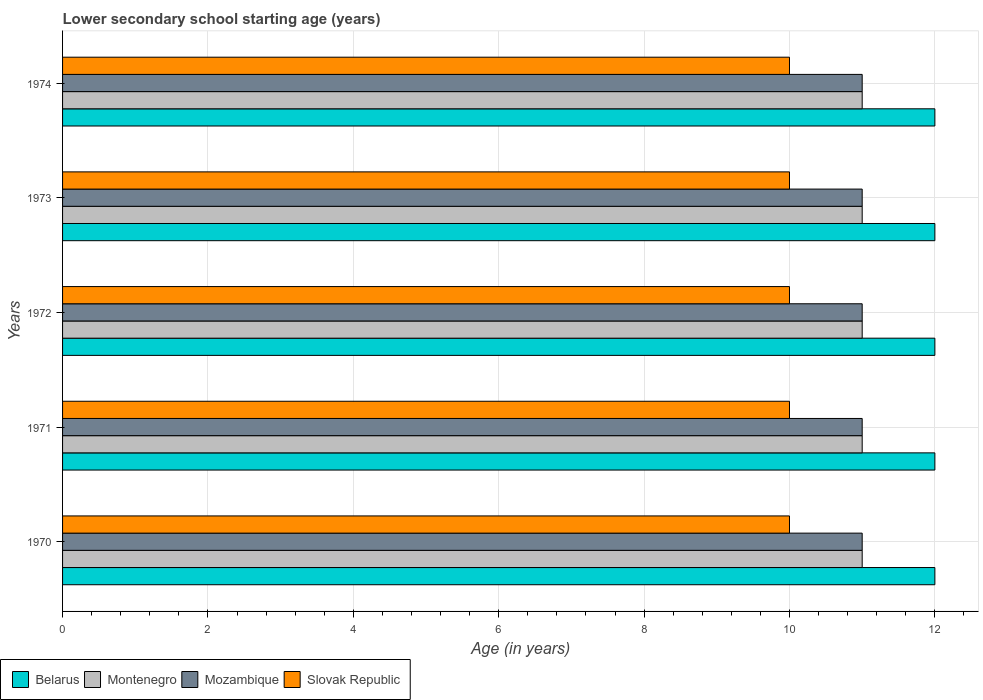How many different coloured bars are there?
Your answer should be compact. 4. Are the number of bars per tick equal to the number of legend labels?
Provide a short and direct response. Yes. Are the number of bars on each tick of the Y-axis equal?
Your answer should be very brief. Yes. How many bars are there on the 4th tick from the bottom?
Give a very brief answer. 4. In how many cases, is the number of bars for a given year not equal to the number of legend labels?
Provide a succinct answer. 0. What is the lower secondary school starting age of children in Montenegro in 1972?
Provide a succinct answer. 11. Across all years, what is the maximum lower secondary school starting age of children in Montenegro?
Your response must be concise. 11. Across all years, what is the minimum lower secondary school starting age of children in Mozambique?
Make the answer very short. 11. In which year was the lower secondary school starting age of children in Slovak Republic maximum?
Your answer should be compact. 1970. In which year was the lower secondary school starting age of children in Montenegro minimum?
Provide a short and direct response. 1970. What is the total lower secondary school starting age of children in Belarus in the graph?
Your response must be concise. 60. What is the difference between the lower secondary school starting age of children in Montenegro in 1972 and that in 1974?
Your response must be concise. 0. What is the difference between the lower secondary school starting age of children in Slovak Republic in 1971 and the lower secondary school starting age of children in Montenegro in 1974?
Provide a short and direct response. -1. What is the average lower secondary school starting age of children in Belarus per year?
Your response must be concise. 12. In the year 1970, what is the difference between the lower secondary school starting age of children in Montenegro and lower secondary school starting age of children in Mozambique?
Offer a terse response. 0. What is the ratio of the lower secondary school starting age of children in Belarus in 1972 to that in 1973?
Your answer should be compact. 1. Is the lower secondary school starting age of children in Mozambique in 1971 less than that in 1972?
Offer a very short reply. No. Is the difference between the lower secondary school starting age of children in Montenegro in 1972 and 1973 greater than the difference between the lower secondary school starting age of children in Mozambique in 1972 and 1973?
Ensure brevity in your answer.  No. What is the difference between the highest and the second highest lower secondary school starting age of children in Slovak Republic?
Your response must be concise. 0. What is the difference between the highest and the lowest lower secondary school starting age of children in Montenegro?
Offer a terse response. 0. Is the sum of the lower secondary school starting age of children in Slovak Republic in 1971 and 1974 greater than the maximum lower secondary school starting age of children in Mozambique across all years?
Ensure brevity in your answer.  Yes. Is it the case that in every year, the sum of the lower secondary school starting age of children in Mozambique and lower secondary school starting age of children in Belarus is greater than the sum of lower secondary school starting age of children in Slovak Republic and lower secondary school starting age of children in Montenegro?
Your response must be concise. Yes. What does the 1st bar from the top in 1971 represents?
Provide a succinct answer. Slovak Republic. What does the 2nd bar from the bottom in 1974 represents?
Offer a very short reply. Montenegro. How many bars are there?
Provide a succinct answer. 20. Are all the bars in the graph horizontal?
Make the answer very short. Yes. Are the values on the major ticks of X-axis written in scientific E-notation?
Give a very brief answer. No. Where does the legend appear in the graph?
Your response must be concise. Bottom left. How many legend labels are there?
Your answer should be compact. 4. How are the legend labels stacked?
Offer a very short reply. Horizontal. What is the title of the graph?
Offer a terse response. Lower secondary school starting age (years). What is the label or title of the X-axis?
Keep it short and to the point. Age (in years). What is the Age (in years) of Belarus in 1970?
Your answer should be compact. 12. What is the Age (in years) of Montenegro in 1970?
Your answer should be compact. 11. What is the Age (in years) in Mozambique in 1970?
Offer a terse response. 11. What is the Age (in years) of Montenegro in 1971?
Provide a short and direct response. 11. What is the Age (in years) in Belarus in 1973?
Ensure brevity in your answer.  12. What is the Age (in years) of Mozambique in 1973?
Your response must be concise. 11. What is the Age (in years) in Slovak Republic in 1973?
Make the answer very short. 10. What is the Age (in years) of Belarus in 1974?
Offer a terse response. 12. What is the Age (in years) in Slovak Republic in 1974?
Your answer should be compact. 10. Across all years, what is the maximum Age (in years) of Mozambique?
Your response must be concise. 11. Across all years, what is the maximum Age (in years) in Slovak Republic?
Your response must be concise. 10. Across all years, what is the minimum Age (in years) in Montenegro?
Your answer should be compact. 11. Across all years, what is the minimum Age (in years) in Mozambique?
Make the answer very short. 11. Across all years, what is the minimum Age (in years) in Slovak Republic?
Offer a terse response. 10. What is the total Age (in years) in Belarus in the graph?
Offer a terse response. 60. What is the total Age (in years) of Slovak Republic in the graph?
Keep it short and to the point. 50. What is the difference between the Age (in years) of Belarus in 1970 and that in 1971?
Offer a terse response. 0. What is the difference between the Age (in years) of Mozambique in 1970 and that in 1971?
Offer a terse response. 0. What is the difference between the Age (in years) in Slovak Republic in 1970 and that in 1971?
Give a very brief answer. 0. What is the difference between the Age (in years) in Belarus in 1970 and that in 1972?
Your answer should be very brief. 0. What is the difference between the Age (in years) in Montenegro in 1970 and that in 1972?
Ensure brevity in your answer.  0. What is the difference between the Age (in years) of Slovak Republic in 1970 and that in 1972?
Give a very brief answer. 0. What is the difference between the Age (in years) of Belarus in 1970 and that in 1973?
Keep it short and to the point. 0. What is the difference between the Age (in years) of Mozambique in 1970 and that in 1973?
Give a very brief answer. 0. What is the difference between the Age (in years) in Slovak Republic in 1970 and that in 1973?
Your answer should be very brief. 0. What is the difference between the Age (in years) in Belarus in 1970 and that in 1974?
Give a very brief answer. 0. What is the difference between the Age (in years) in Montenegro in 1970 and that in 1974?
Ensure brevity in your answer.  0. What is the difference between the Age (in years) of Mozambique in 1970 and that in 1974?
Make the answer very short. 0. What is the difference between the Age (in years) of Belarus in 1971 and that in 1972?
Provide a short and direct response. 0. What is the difference between the Age (in years) in Montenegro in 1971 and that in 1972?
Ensure brevity in your answer.  0. What is the difference between the Age (in years) of Mozambique in 1971 and that in 1972?
Make the answer very short. 0. What is the difference between the Age (in years) in Belarus in 1971 and that in 1973?
Offer a terse response. 0. What is the difference between the Age (in years) of Montenegro in 1971 and that in 1973?
Your answer should be very brief. 0. What is the difference between the Age (in years) of Mozambique in 1971 and that in 1973?
Give a very brief answer. 0. What is the difference between the Age (in years) of Mozambique in 1971 and that in 1974?
Offer a terse response. 0. What is the difference between the Age (in years) of Belarus in 1972 and that in 1973?
Your answer should be very brief. 0. What is the difference between the Age (in years) in Montenegro in 1972 and that in 1973?
Keep it short and to the point. 0. What is the difference between the Age (in years) in Slovak Republic in 1972 and that in 1973?
Your answer should be compact. 0. What is the difference between the Age (in years) of Belarus in 1972 and that in 1974?
Offer a terse response. 0. What is the difference between the Age (in years) in Mozambique in 1972 and that in 1974?
Your answer should be compact. 0. What is the difference between the Age (in years) of Slovak Republic in 1972 and that in 1974?
Ensure brevity in your answer.  0. What is the difference between the Age (in years) in Belarus in 1973 and that in 1974?
Provide a succinct answer. 0. What is the difference between the Age (in years) in Montenegro in 1973 and that in 1974?
Make the answer very short. 0. What is the difference between the Age (in years) in Belarus in 1970 and the Age (in years) in Montenegro in 1971?
Your answer should be very brief. 1. What is the difference between the Age (in years) of Belarus in 1970 and the Age (in years) of Slovak Republic in 1971?
Keep it short and to the point. 2. What is the difference between the Age (in years) of Montenegro in 1970 and the Age (in years) of Slovak Republic in 1971?
Offer a terse response. 1. What is the difference between the Age (in years) in Belarus in 1970 and the Age (in years) in Montenegro in 1972?
Make the answer very short. 1. What is the difference between the Age (in years) in Montenegro in 1970 and the Age (in years) in Mozambique in 1972?
Keep it short and to the point. 0. What is the difference between the Age (in years) in Montenegro in 1970 and the Age (in years) in Slovak Republic in 1972?
Offer a terse response. 1. What is the difference between the Age (in years) of Belarus in 1970 and the Age (in years) of Montenegro in 1973?
Provide a succinct answer. 1. What is the difference between the Age (in years) in Belarus in 1970 and the Age (in years) in Mozambique in 1973?
Offer a very short reply. 1. What is the difference between the Age (in years) of Belarus in 1970 and the Age (in years) of Slovak Republic in 1973?
Your answer should be compact. 2. What is the difference between the Age (in years) of Montenegro in 1970 and the Age (in years) of Mozambique in 1973?
Provide a succinct answer. 0. What is the difference between the Age (in years) of Montenegro in 1970 and the Age (in years) of Slovak Republic in 1973?
Make the answer very short. 1. What is the difference between the Age (in years) in Mozambique in 1970 and the Age (in years) in Slovak Republic in 1973?
Offer a terse response. 1. What is the difference between the Age (in years) of Belarus in 1970 and the Age (in years) of Mozambique in 1974?
Keep it short and to the point. 1. What is the difference between the Age (in years) in Montenegro in 1970 and the Age (in years) in Mozambique in 1974?
Keep it short and to the point. 0. What is the difference between the Age (in years) of Montenegro in 1970 and the Age (in years) of Slovak Republic in 1974?
Your answer should be compact. 1. What is the difference between the Age (in years) in Mozambique in 1970 and the Age (in years) in Slovak Republic in 1974?
Your answer should be very brief. 1. What is the difference between the Age (in years) in Mozambique in 1971 and the Age (in years) in Slovak Republic in 1972?
Your answer should be compact. 1. What is the difference between the Age (in years) in Belarus in 1971 and the Age (in years) in Mozambique in 1973?
Give a very brief answer. 1. What is the difference between the Age (in years) of Belarus in 1971 and the Age (in years) of Slovak Republic in 1973?
Keep it short and to the point. 2. What is the difference between the Age (in years) of Montenegro in 1971 and the Age (in years) of Mozambique in 1973?
Make the answer very short. 0. What is the difference between the Age (in years) of Montenegro in 1971 and the Age (in years) of Slovak Republic in 1973?
Your answer should be very brief. 1. What is the difference between the Age (in years) in Belarus in 1971 and the Age (in years) in Montenegro in 1974?
Your answer should be very brief. 1. What is the difference between the Age (in years) of Belarus in 1971 and the Age (in years) of Slovak Republic in 1974?
Provide a short and direct response. 2. What is the difference between the Age (in years) in Montenegro in 1971 and the Age (in years) in Slovak Republic in 1974?
Your answer should be very brief. 1. What is the difference between the Age (in years) in Mozambique in 1971 and the Age (in years) in Slovak Republic in 1974?
Make the answer very short. 1. What is the difference between the Age (in years) of Belarus in 1972 and the Age (in years) of Montenegro in 1973?
Keep it short and to the point. 1. What is the difference between the Age (in years) of Belarus in 1972 and the Age (in years) of Slovak Republic in 1973?
Offer a very short reply. 2. What is the difference between the Age (in years) of Montenegro in 1972 and the Age (in years) of Slovak Republic in 1973?
Your answer should be very brief. 1. What is the difference between the Age (in years) in Mozambique in 1972 and the Age (in years) in Slovak Republic in 1973?
Offer a terse response. 1. What is the difference between the Age (in years) of Belarus in 1972 and the Age (in years) of Montenegro in 1974?
Your answer should be compact. 1. What is the difference between the Age (in years) in Mozambique in 1972 and the Age (in years) in Slovak Republic in 1974?
Ensure brevity in your answer.  1. What is the difference between the Age (in years) in Belarus in 1973 and the Age (in years) in Montenegro in 1974?
Offer a terse response. 1. What is the difference between the Age (in years) in Montenegro in 1973 and the Age (in years) in Mozambique in 1974?
Offer a very short reply. 0. What is the difference between the Age (in years) in Mozambique in 1973 and the Age (in years) in Slovak Republic in 1974?
Offer a very short reply. 1. What is the average Age (in years) in Montenegro per year?
Keep it short and to the point. 11. What is the average Age (in years) in Mozambique per year?
Ensure brevity in your answer.  11. What is the average Age (in years) of Slovak Republic per year?
Your response must be concise. 10. In the year 1970, what is the difference between the Age (in years) of Belarus and Age (in years) of Montenegro?
Provide a short and direct response. 1. In the year 1970, what is the difference between the Age (in years) of Belarus and Age (in years) of Mozambique?
Give a very brief answer. 1. In the year 1970, what is the difference between the Age (in years) of Belarus and Age (in years) of Slovak Republic?
Your response must be concise. 2. In the year 1970, what is the difference between the Age (in years) in Montenegro and Age (in years) in Mozambique?
Give a very brief answer. 0. In the year 1971, what is the difference between the Age (in years) of Belarus and Age (in years) of Montenegro?
Your answer should be very brief. 1. In the year 1972, what is the difference between the Age (in years) of Belarus and Age (in years) of Mozambique?
Make the answer very short. 1. In the year 1972, what is the difference between the Age (in years) of Belarus and Age (in years) of Slovak Republic?
Give a very brief answer. 2. In the year 1972, what is the difference between the Age (in years) in Mozambique and Age (in years) in Slovak Republic?
Give a very brief answer. 1. In the year 1973, what is the difference between the Age (in years) in Belarus and Age (in years) in Montenegro?
Provide a succinct answer. 1. In the year 1973, what is the difference between the Age (in years) of Belarus and Age (in years) of Mozambique?
Give a very brief answer. 1. In the year 1973, what is the difference between the Age (in years) in Montenegro and Age (in years) in Mozambique?
Provide a short and direct response. 0. In the year 1973, what is the difference between the Age (in years) of Mozambique and Age (in years) of Slovak Republic?
Offer a very short reply. 1. In the year 1974, what is the difference between the Age (in years) in Montenegro and Age (in years) in Slovak Republic?
Your answer should be compact. 1. In the year 1974, what is the difference between the Age (in years) in Mozambique and Age (in years) in Slovak Republic?
Your response must be concise. 1. What is the ratio of the Age (in years) in Slovak Republic in 1970 to that in 1971?
Offer a terse response. 1. What is the ratio of the Age (in years) of Belarus in 1970 to that in 1972?
Provide a short and direct response. 1. What is the ratio of the Age (in years) of Montenegro in 1970 to that in 1973?
Your answer should be compact. 1. What is the ratio of the Age (in years) of Mozambique in 1970 to that in 1973?
Provide a succinct answer. 1. What is the ratio of the Age (in years) of Belarus in 1970 to that in 1974?
Your answer should be very brief. 1. What is the ratio of the Age (in years) of Mozambique in 1970 to that in 1974?
Ensure brevity in your answer.  1. What is the ratio of the Age (in years) in Belarus in 1971 to that in 1972?
Offer a very short reply. 1. What is the ratio of the Age (in years) in Mozambique in 1971 to that in 1972?
Give a very brief answer. 1. What is the ratio of the Age (in years) in Montenegro in 1971 to that in 1973?
Provide a short and direct response. 1. What is the ratio of the Age (in years) in Mozambique in 1971 to that in 1973?
Your answer should be very brief. 1. What is the ratio of the Age (in years) in Slovak Republic in 1971 to that in 1973?
Make the answer very short. 1. What is the ratio of the Age (in years) in Slovak Republic in 1971 to that in 1974?
Provide a short and direct response. 1. What is the ratio of the Age (in years) in Belarus in 1972 to that in 1973?
Give a very brief answer. 1. What is the ratio of the Age (in years) in Montenegro in 1972 to that in 1973?
Give a very brief answer. 1. What is the ratio of the Age (in years) of Slovak Republic in 1972 to that in 1974?
Offer a terse response. 1. What is the ratio of the Age (in years) of Belarus in 1973 to that in 1974?
Keep it short and to the point. 1. What is the ratio of the Age (in years) of Montenegro in 1973 to that in 1974?
Your answer should be very brief. 1. What is the ratio of the Age (in years) of Mozambique in 1973 to that in 1974?
Keep it short and to the point. 1. What is the difference between the highest and the second highest Age (in years) of Belarus?
Keep it short and to the point. 0. What is the difference between the highest and the second highest Age (in years) in Montenegro?
Ensure brevity in your answer.  0. What is the difference between the highest and the second highest Age (in years) in Mozambique?
Give a very brief answer. 0. What is the difference between the highest and the lowest Age (in years) in Belarus?
Give a very brief answer. 0. What is the difference between the highest and the lowest Age (in years) of Montenegro?
Offer a very short reply. 0. What is the difference between the highest and the lowest Age (in years) in Mozambique?
Your answer should be compact. 0. What is the difference between the highest and the lowest Age (in years) in Slovak Republic?
Your response must be concise. 0. 